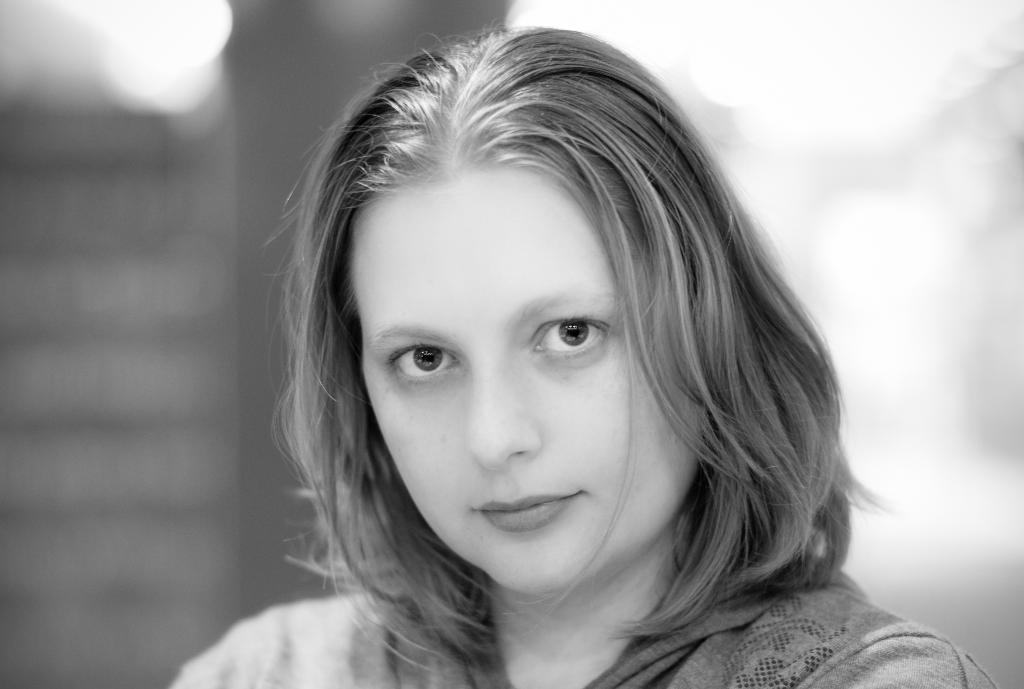Please provide a concise description of this image. In the image in the center there is a woman. In the background we can see wall etc. 